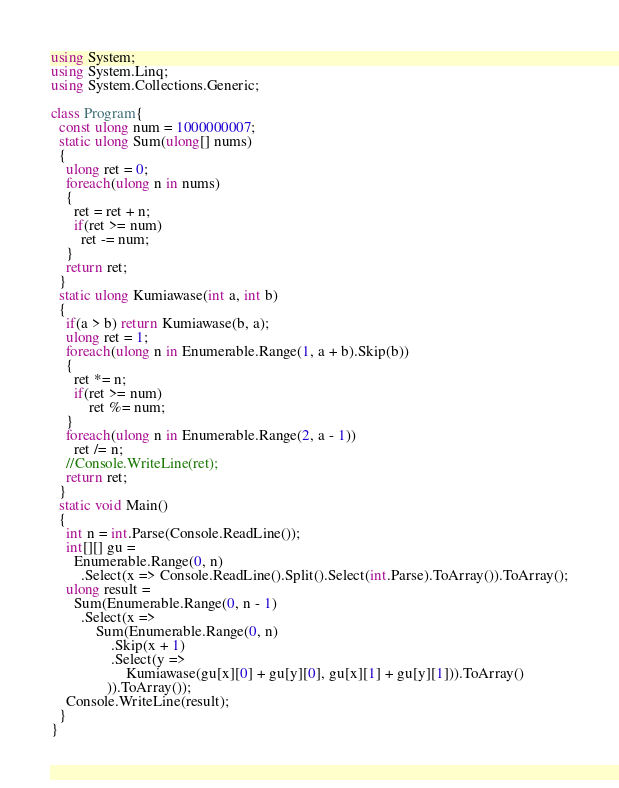<code> <loc_0><loc_0><loc_500><loc_500><_C#_>using System;
using System.Linq;
using System.Collections.Generic;

class Program{
  const ulong num = 1000000007;
  static ulong Sum(ulong[] nums)
  {
    ulong ret = 0;
    foreach(ulong n in nums)
    {
      ret = ret + n;
      if(ret >= num)
        ret -= num;
    }
    return ret;
  }
  static ulong Kumiawase(int a, int b)
  {
    if(a > b) return Kumiawase(b, a);
    ulong ret = 1;
    foreach(ulong n in Enumerable.Range(1, a + b).Skip(b))
    {
      ret *= n;
      if(ret >= num)
	      ret %= num;
    }
    foreach(ulong n in Enumerable.Range(2, a - 1))
      ret /= n;
    //Console.WriteLine(ret);
    return ret;
  }
  static void Main()
  {
    int n = int.Parse(Console.ReadLine());
    int[][] gu = 
      Enumerable.Range(0, n)
      	.Select(x => Console.ReadLine().Split().Select(int.Parse).ToArray()).ToArray();
    ulong result =
      Sum(Enumerable.Range(0, n - 1)
      	.Select(x =>
            Sum(Enumerable.Range(0, n)
                .Skip(x + 1)
                .Select(y => 
                    Kumiawase(gu[x][0] + gu[y][0], gu[x][1] + gu[y][1])).ToArray()
               )).ToArray());
    Console.WriteLine(result);
  }
}
</code> 